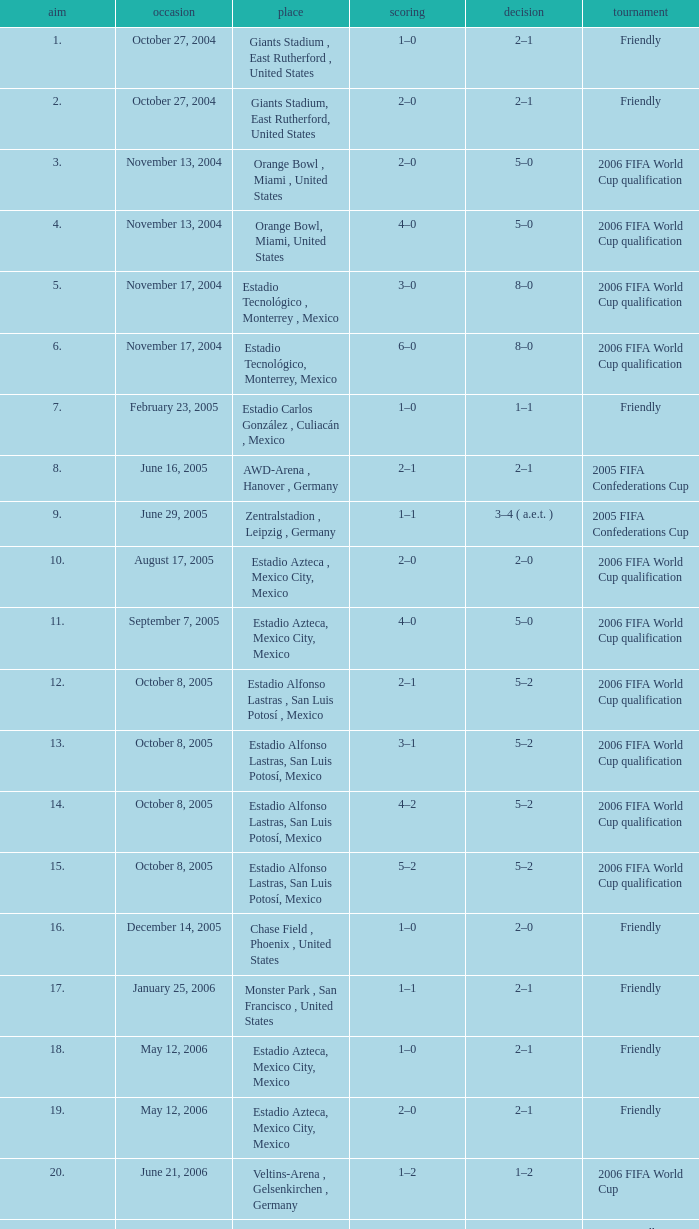Could you help me parse every detail presented in this table? {'header': ['aim', 'occasion', 'place', 'scoring', 'decision', 'tournament'], 'rows': [['1.', 'October 27, 2004', 'Giants Stadium , East Rutherford , United States', '1–0', '2–1', 'Friendly'], ['2.', 'October 27, 2004', 'Giants Stadium, East Rutherford, United States', '2–0', '2–1', 'Friendly'], ['3.', 'November 13, 2004', 'Orange Bowl , Miami , United States', '2–0', '5–0', '2006 FIFA World Cup qualification'], ['4.', 'November 13, 2004', 'Orange Bowl, Miami, United States', '4–0', '5–0', '2006 FIFA World Cup qualification'], ['5.', 'November 17, 2004', 'Estadio Tecnológico , Monterrey , Mexico', '3–0', '8–0', '2006 FIFA World Cup qualification'], ['6.', 'November 17, 2004', 'Estadio Tecnológico, Monterrey, Mexico', '6–0', '8–0', '2006 FIFA World Cup qualification'], ['7.', 'February 23, 2005', 'Estadio Carlos González , Culiacán , Mexico', '1–0', '1–1', 'Friendly'], ['8.', 'June 16, 2005', 'AWD-Arena , Hanover , Germany', '2–1', '2–1', '2005 FIFA Confederations Cup'], ['9.', 'June 29, 2005', 'Zentralstadion , Leipzig , Germany', '1–1', '3–4 ( a.e.t. )', '2005 FIFA Confederations Cup'], ['10.', 'August 17, 2005', 'Estadio Azteca , Mexico City, Mexico', '2–0', '2–0', '2006 FIFA World Cup qualification'], ['11.', 'September 7, 2005', 'Estadio Azteca, Mexico City, Mexico', '4–0', '5–0', '2006 FIFA World Cup qualification'], ['12.', 'October 8, 2005', 'Estadio Alfonso Lastras , San Luis Potosí , Mexico', '2–1', '5–2', '2006 FIFA World Cup qualification'], ['13.', 'October 8, 2005', 'Estadio Alfonso Lastras, San Luis Potosí, Mexico', '3–1', '5–2', '2006 FIFA World Cup qualification'], ['14.', 'October 8, 2005', 'Estadio Alfonso Lastras, San Luis Potosí, Mexico', '4–2', '5–2', '2006 FIFA World Cup qualification'], ['15.', 'October 8, 2005', 'Estadio Alfonso Lastras, San Luis Potosí, Mexico', '5–2', '5–2', '2006 FIFA World Cup qualification'], ['16.', 'December 14, 2005', 'Chase Field , Phoenix , United States', '1–0', '2–0', 'Friendly'], ['17.', 'January 25, 2006', 'Monster Park , San Francisco , United States', '1–1', '2–1', 'Friendly'], ['18.', 'May 12, 2006', 'Estadio Azteca, Mexico City, Mexico', '1–0', '2–1', 'Friendly'], ['19.', 'May 12, 2006', 'Estadio Azteca, Mexico City, Mexico', '2–0', '2–1', 'Friendly'], ['20.', 'June 21, 2006', 'Veltins-Arena , Gelsenkirchen , Germany', '1–2', '1–2', '2006 FIFA World Cup'], ['21.', 'June 2, 2007', 'Estadio Alfonso Lastras, San Luis Potosí, Mexico', '3–0', '4–0', 'Friendly']]} Which Score has a Result of 2–1, and a Competition of friendly, and a Goal smaller than 17? 1–0, 2–0. 